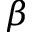<formula> <loc_0><loc_0><loc_500><loc_500>\beta</formula> 